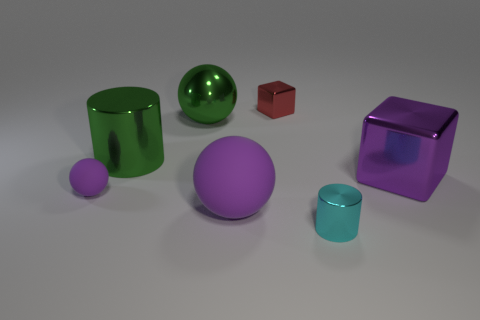Add 2 purple cubes. How many objects exist? 9 Subtract all spheres. How many objects are left? 4 Add 7 red shiny blocks. How many red shiny blocks are left? 8 Add 5 tiny cyan objects. How many tiny cyan objects exist? 6 Subtract 0 gray cubes. How many objects are left? 7 Subtract all big green shiny spheres. Subtract all big metallic things. How many objects are left? 3 